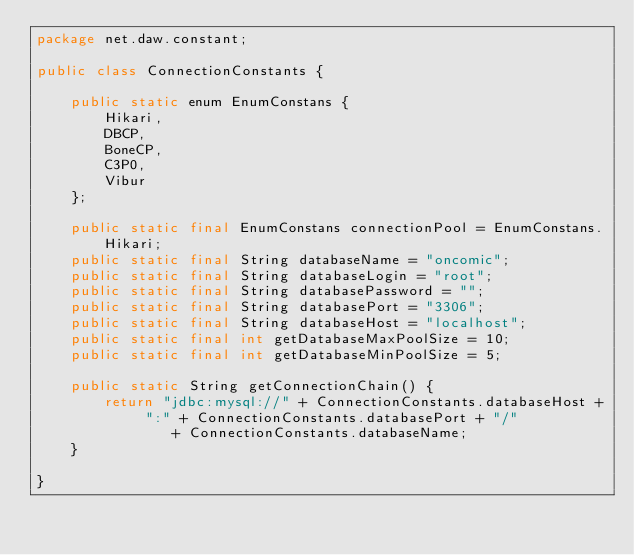<code> <loc_0><loc_0><loc_500><loc_500><_Java_>package net.daw.constant;

public class ConnectionConstants {

    public static enum EnumConstans {
        Hikari,
        DBCP,
        BoneCP,
        C3P0,
        Vibur
    };

    public static final EnumConstans connectionPool = EnumConstans.Hikari;
    public static final String databaseName = "oncomic";
    public static final String databaseLogin = "root";
    public static final String databasePassword = "";
    public static final String databasePort = "3306";
    public static final String databaseHost = "localhost";
    public static final int getDatabaseMaxPoolSize = 10;
    public static final int getDatabaseMinPoolSize = 5;

    public static String getConnectionChain() {
        return "jdbc:mysql://" + ConnectionConstants.databaseHost + ":" + ConnectionConstants.databasePort + "/"
                + ConnectionConstants.databaseName;
    }

}
</code> 